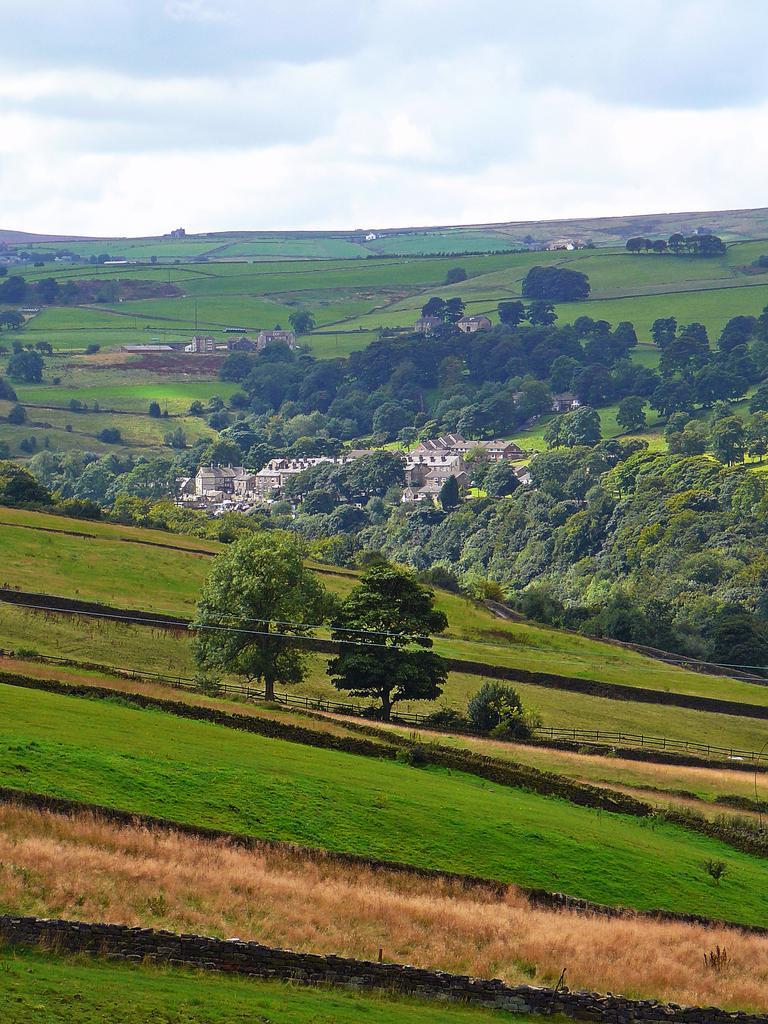What type of vegetation can be seen in the image? There is grass in the image. What other natural elements are present in the image? There are trees in the image. What type of human-made structures can be seen in the image? There are houses and farms in the image. What part of the natural environment is visible in the image? The sky is visible in the image. Can you determine the time of day based on the image? The image appears to be taken during the day. How many drains can be seen in the image? There are no drains present in the image. What type of animal can be seen roaming around the farms in the image? There are no animals, including tigers, visible in the image. 